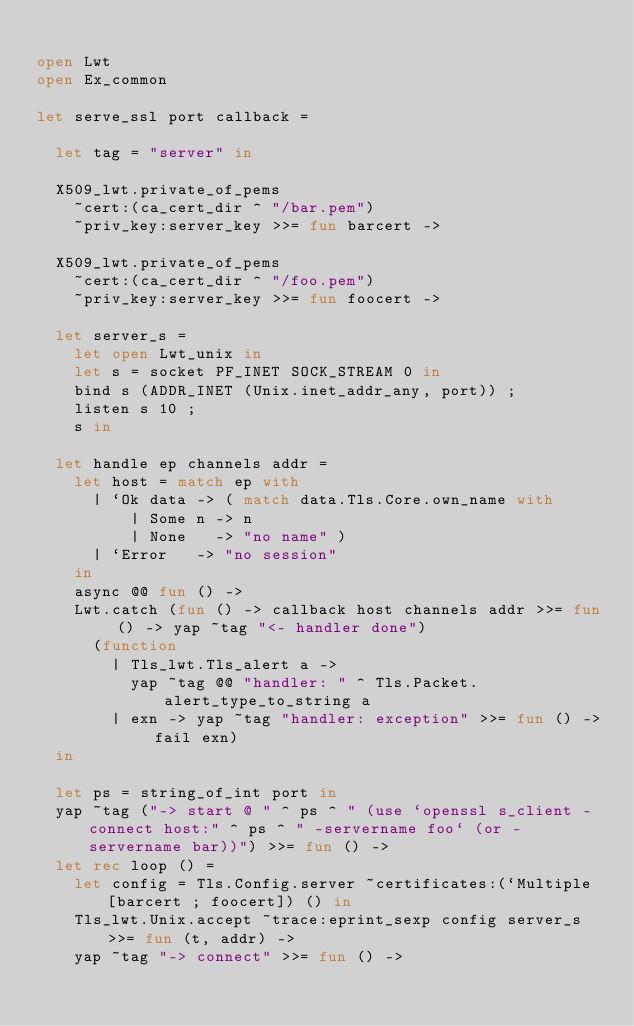Convert code to text. <code><loc_0><loc_0><loc_500><loc_500><_OCaml_>
open Lwt
open Ex_common

let serve_ssl port callback =

  let tag = "server" in

  X509_lwt.private_of_pems
    ~cert:(ca_cert_dir ^ "/bar.pem")
    ~priv_key:server_key >>= fun barcert ->

  X509_lwt.private_of_pems
    ~cert:(ca_cert_dir ^ "/foo.pem")
    ~priv_key:server_key >>= fun foocert ->

  let server_s =
    let open Lwt_unix in
    let s = socket PF_INET SOCK_STREAM 0 in
    bind s (ADDR_INET (Unix.inet_addr_any, port)) ;
    listen s 10 ;
    s in

  let handle ep channels addr =
    let host = match ep with
      | `Ok data -> ( match data.Tls.Core.own_name with
          | Some n -> n
          | None   -> "no name" )
      | `Error   -> "no session"
    in
    async @@ fun () ->
    Lwt.catch (fun () -> callback host channels addr >>= fun () -> yap ~tag "<- handler done")
      (function
        | Tls_lwt.Tls_alert a ->
          yap ~tag @@ "handler: " ^ Tls.Packet.alert_type_to_string a
        | exn -> yap ~tag "handler: exception" >>= fun () -> fail exn)
  in

  let ps = string_of_int port in
  yap ~tag ("-> start @ " ^ ps ^ " (use `openssl s_client -connect host:" ^ ps ^ " -servername foo` (or -servername bar))") >>= fun () ->
  let rec loop () =
    let config = Tls.Config.server ~certificates:(`Multiple [barcert ; foocert]) () in
    Tls_lwt.Unix.accept ~trace:eprint_sexp config server_s >>= fun (t, addr) ->
    yap ~tag "-> connect" >>= fun () -></code> 